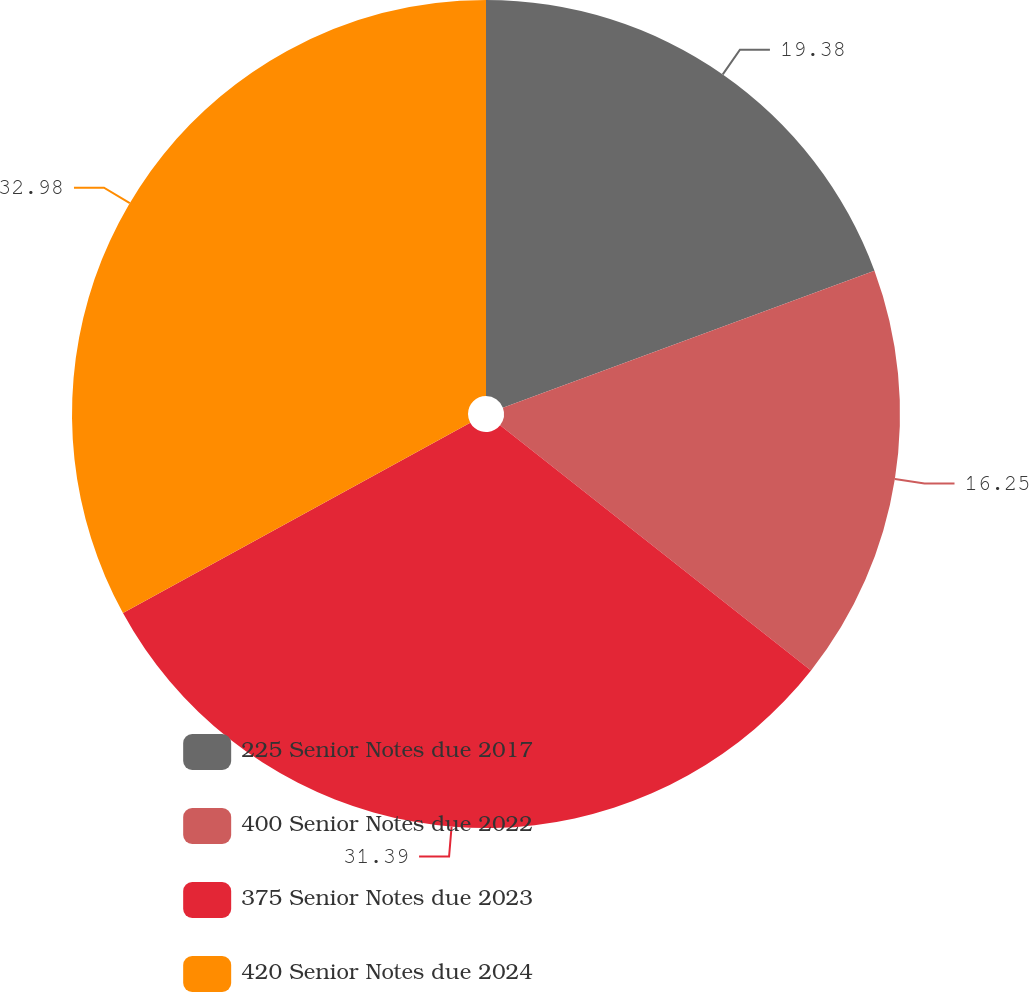Convert chart to OTSL. <chart><loc_0><loc_0><loc_500><loc_500><pie_chart><fcel>225 Senior Notes due 2017<fcel>400 Senior Notes due 2022<fcel>375 Senior Notes due 2023<fcel>420 Senior Notes due 2024<nl><fcel>19.38%<fcel>16.25%<fcel>31.39%<fcel>32.98%<nl></chart> 